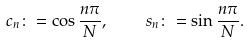Convert formula to latex. <formula><loc_0><loc_0><loc_500><loc_500>c _ { n } \colon = \cos \frac { n \pi } { N } , \quad s _ { n } \colon = \sin \frac { n \pi } { N } .</formula> 